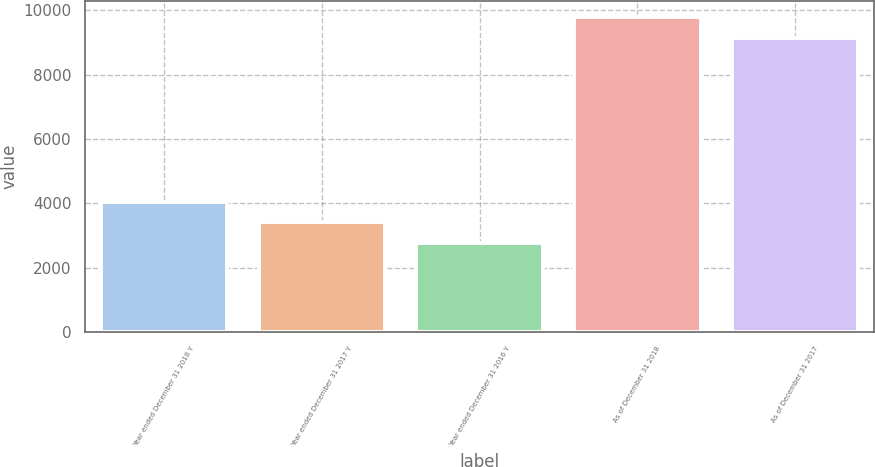Convert chart. <chart><loc_0><loc_0><loc_500><loc_500><bar_chart><fcel>Year ended December 31 2018 Y<fcel>Year ended December 31 2017 Y<fcel>Year ended December 31 2016 Y<fcel>As of December 31 2018<fcel>As of December 31 2017<nl><fcel>4050.8<fcel>3403.9<fcel>2757<fcel>9798.9<fcel>9152<nl></chart> 